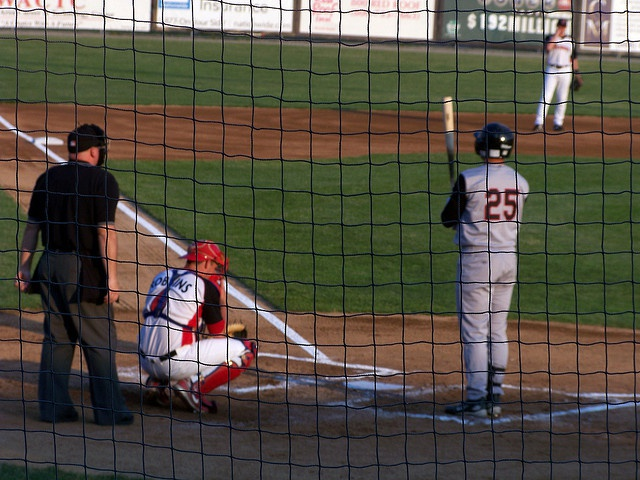Describe the objects in this image and their specific colors. I can see people in salmon, black, brown, and gray tones, people in salmon, darkgray, black, and gray tones, people in salmon, black, lavender, maroon, and brown tones, people in salmon, lavender, black, darkgray, and gray tones, and baseball bat in salmon, black, gray, and tan tones in this image. 